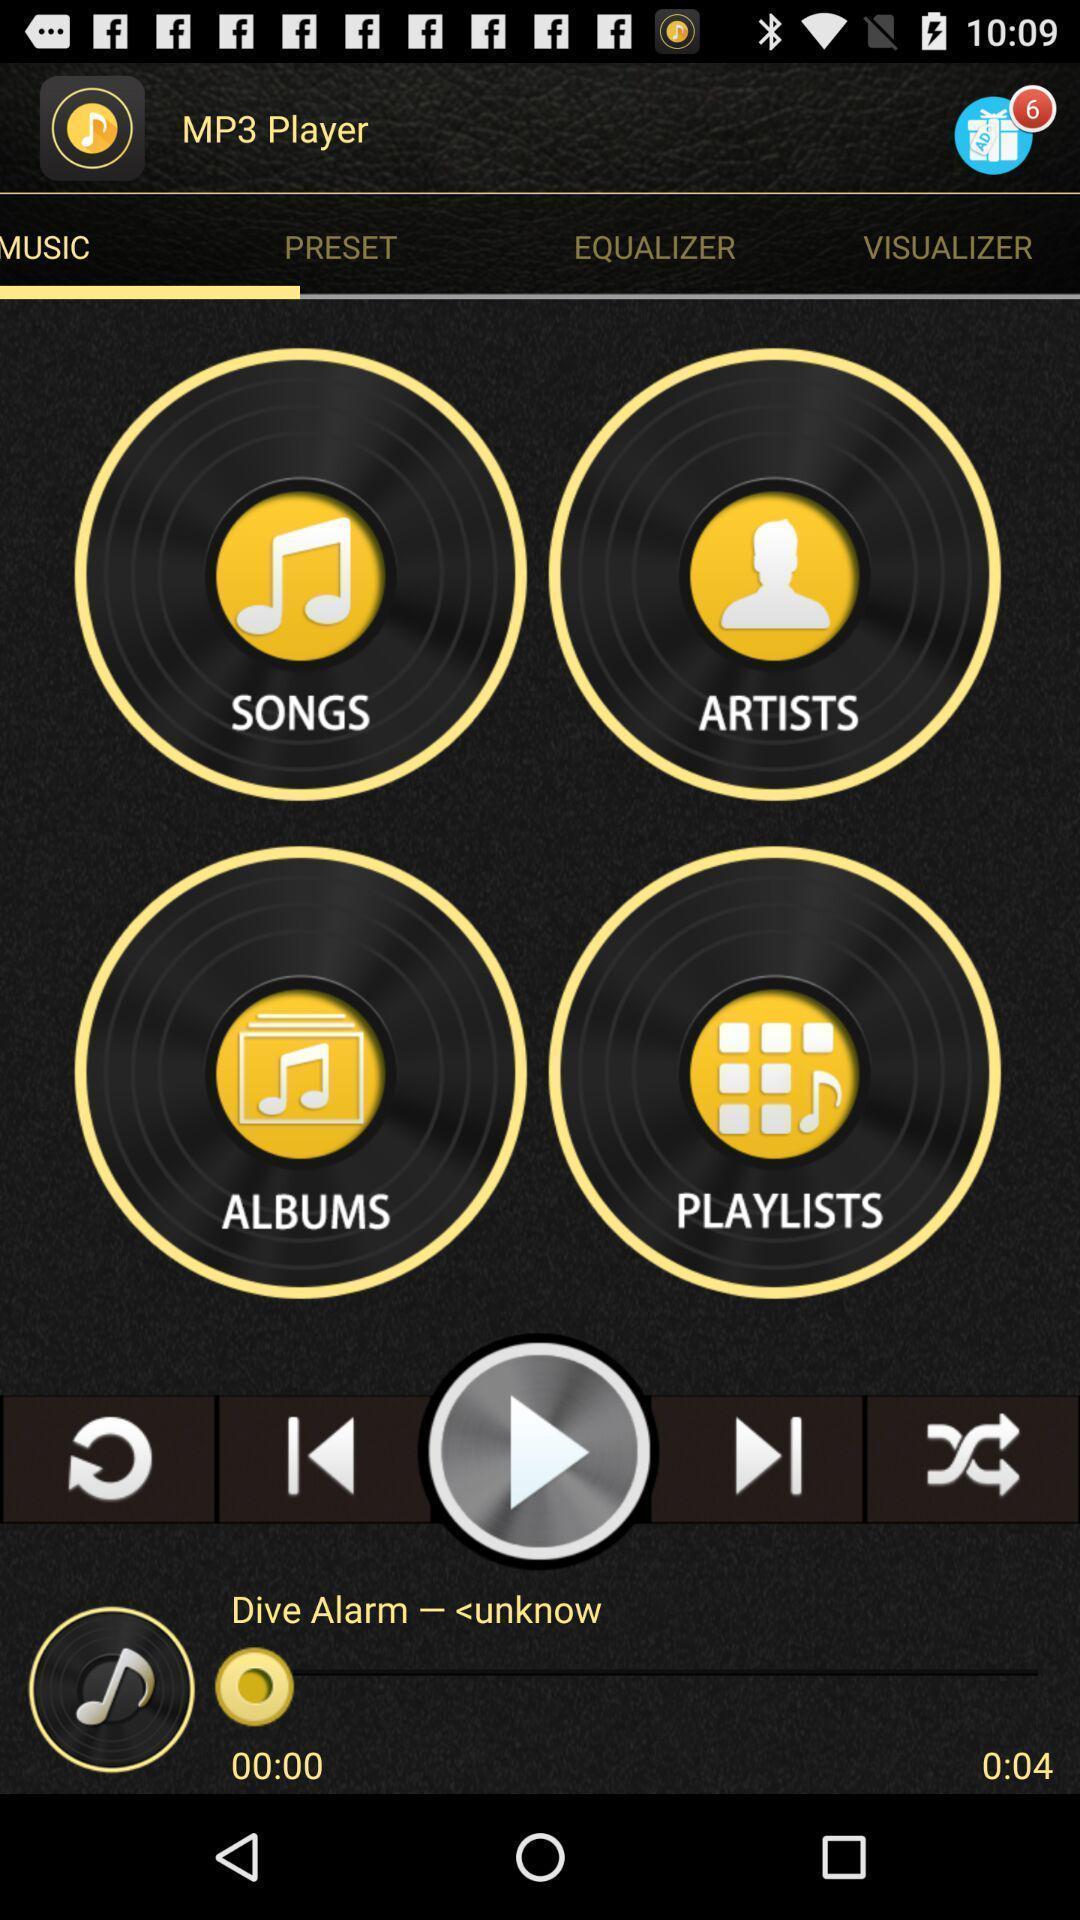Give me a narrative description of this picture. Screen page of music player application. 